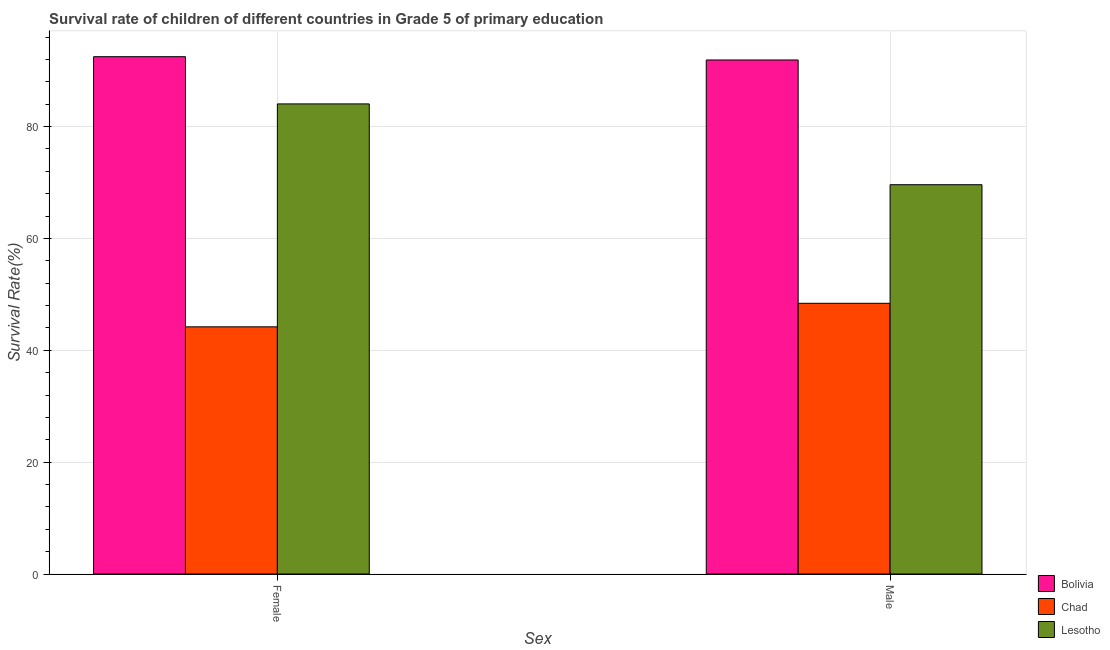How many groups of bars are there?
Ensure brevity in your answer.  2. Are the number of bars per tick equal to the number of legend labels?
Keep it short and to the point. Yes. Are the number of bars on each tick of the X-axis equal?
Offer a terse response. Yes. How many bars are there on the 2nd tick from the left?
Offer a terse response. 3. What is the label of the 1st group of bars from the left?
Provide a succinct answer. Female. What is the survival rate of female students in primary education in Bolivia?
Ensure brevity in your answer.  92.5. Across all countries, what is the maximum survival rate of male students in primary education?
Give a very brief answer. 91.92. Across all countries, what is the minimum survival rate of female students in primary education?
Give a very brief answer. 44.2. In which country was the survival rate of male students in primary education maximum?
Provide a succinct answer. Bolivia. In which country was the survival rate of male students in primary education minimum?
Your response must be concise. Chad. What is the total survival rate of male students in primary education in the graph?
Your response must be concise. 209.94. What is the difference between the survival rate of female students in primary education in Lesotho and that in Bolivia?
Offer a very short reply. -8.44. What is the difference between the survival rate of male students in primary education in Bolivia and the survival rate of female students in primary education in Chad?
Provide a succinct answer. 47.72. What is the average survival rate of female students in primary education per country?
Give a very brief answer. 73.59. What is the difference between the survival rate of female students in primary education and survival rate of male students in primary education in Lesotho?
Your answer should be very brief. 14.45. In how many countries, is the survival rate of female students in primary education greater than 4 %?
Provide a succinct answer. 3. What is the ratio of the survival rate of female students in primary education in Chad to that in Bolivia?
Your response must be concise. 0.48. What does the 3rd bar from the left in Male represents?
Your answer should be very brief. Lesotho. How many bars are there?
Ensure brevity in your answer.  6. How many countries are there in the graph?
Your answer should be very brief. 3. Are the values on the major ticks of Y-axis written in scientific E-notation?
Your answer should be compact. No. Does the graph contain any zero values?
Your answer should be compact. No. Does the graph contain grids?
Make the answer very short. Yes. Where does the legend appear in the graph?
Ensure brevity in your answer.  Bottom right. What is the title of the graph?
Provide a succinct answer. Survival rate of children of different countries in Grade 5 of primary education. What is the label or title of the X-axis?
Provide a succinct answer. Sex. What is the label or title of the Y-axis?
Provide a succinct answer. Survival Rate(%). What is the Survival Rate(%) of Bolivia in Female?
Your answer should be very brief. 92.5. What is the Survival Rate(%) in Chad in Female?
Offer a very short reply. 44.2. What is the Survival Rate(%) of Lesotho in Female?
Your answer should be very brief. 84.06. What is the Survival Rate(%) in Bolivia in Male?
Give a very brief answer. 91.92. What is the Survival Rate(%) of Chad in Male?
Your answer should be very brief. 48.41. What is the Survival Rate(%) of Lesotho in Male?
Your answer should be very brief. 69.61. Across all Sex, what is the maximum Survival Rate(%) of Bolivia?
Your answer should be compact. 92.5. Across all Sex, what is the maximum Survival Rate(%) in Chad?
Provide a short and direct response. 48.41. Across all Sex, what is the maximum Survival Rate(%) of Lesotho?
Ensure brevity in your answer.  84.06. Across all Sex, what is the minimum Survival Rate(%) of Bolivia?
Your answer should be very brief. 91.92. Across all Sex, what is the minimum Survival Rate(%) of Chad?
Give a very brief answer. 44.2. Across all Sex, what is the minimum Survival Rate(%) in Lesotho?
Your response must be concise. 69.61. What is the total Survival Rate(%) in Bolivia in the graph?
Provide a succinct answer. 184.42. What is the total Survival Rate(%) in Chad in the graph?
Your response must be concise. 92.6. What is the total Survival Rate(%) of Lesotho in the graph?
Your answer should be very brief. 153.67. What is the difference between the Survival Rate(%) of Bolivia in Female and that in Male?
Keep it short and to the point. 0.59. What is the difference between the Survival Rate(%) of Chad in Female and that in Male?
Provide a succinct answer. -4.21. What is the difference between the Survival Rate(%) of Lesotho in Female and that in Male?
Offer a terse response. 14.45. What is the difference between the Survival Rate(%) in Bolivia in Female and the Survival Rate(%) in Chad in Male?
Your answer should be compact. 44.1. What is the difference between the Survival Rate(%) in Bolivia in Female and the Survival Rate(%) in Lesotho in Male?
Make the answer very short. 22.89. What is the difference between the Survival Rate(%) of Chad in Female and the Survival Rate(%) of Lesotho in Male?
Provide a succinct answer. -25.41. What is the average Survival Rate(%) of Bolivia per Sex?
Your response must be concise. 92.21. What is the average Survival Rate(%) in Chad per Sex?
Your answer should be very brief. 46.3. What is the average Survival Rate(%) of Lesotho per Sex?
Give a very brief answer. 76.84. What is the difference between the Survival Rate(%) of Bolivia and Survival Rate(%) of Chad in Female?
Provide a succinct answer. 48.31. What is the difference between the Survival Rate(%) in Bolivia and Survival Rate(%) in Lesotho in Female?
Offer a terse response. 8.44. What is the difference between the Survival Rate(%) in Chad and Survival Rate(%) in Lesotho in Female?
Your answer should be very brief. -39.86. What is the difference between the Survival Rate(%) of Bolivia and Survival Rate(%) of Chad in Male?
Your answer should be compact. 43.51. What is the difference between the Survival Rate(%) in Bolivia and Survival Rate(%) in Lesotho in Male?
Your response must be concise. 22.3. What is the difference between the Survival Rate(%) in Chad and Survival Rate(%) in Lesotho in Male?
Your response must be concise. -21.21. What is the ratio of the Survival Rate(%) of Bolivia in Female to that in Male?
Offer a very short reply. 1.01. What is the ratio of the Survival Rate(%) in Chad in Female to that in Male?
Provide a short and direct response. 0.91. What is the ratio of the Survival Rate(%) in Lesotho in Female to that in Male?
Ensure brevity in your answer.  1.21. What is the difference between the highest and the second highest Survival Rate(%) of Bolivia?
Give a very brief answer. 0.59. What is the difference between the highest and the second highest Survival Rate(%) in Chad?
Keep it short and to the point. 4.21. What is the difference between the highest and the second highest Survival Rate(%) in Lesotho?
Offer a terse response. 14.45. What is the difference between the highest and the lowest Survival Rate(%) of Bolivia?
Your answer should be very brief. 0.59. What is the difference between the highest and the lowest Survival Rate(%) of Chad?
Offer a very short reply. 4.21. What is the difference between the highest and the lowest Survival Rate(%) of Lesotho?
Your answer should be compact. 14.45. 